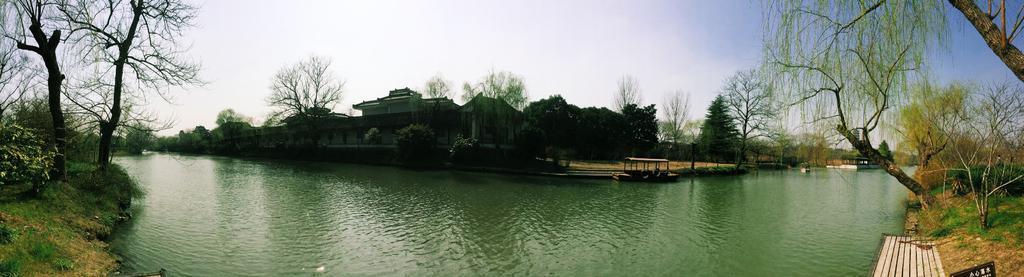Can you describe this image briefly? In this image at the bottom there is a river, and on the right side and left side there is some grass, and, plants. And in the background there are some houses, trees, and sand boat. And at the top there is sky, and on the right side of the image there is a wooden board. 